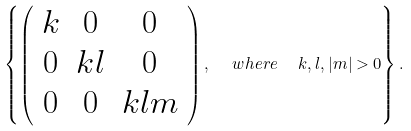<formula> <loc_0><loc_0><loc_500><loc_500>\left \{ \left ( \begin{array} { c c c } k & 0 & 0 \\ 0 & k l & 0 \\ 0 & 0 & k l m \end{array} \right ) , \ \ w h e r e \ \ k , l , | m | > 0 \right \} .</formula> 